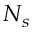Convert formula to latex. <formula><loc_0><loc_0><loc_500><loc_500>N _ { s }</formula> 